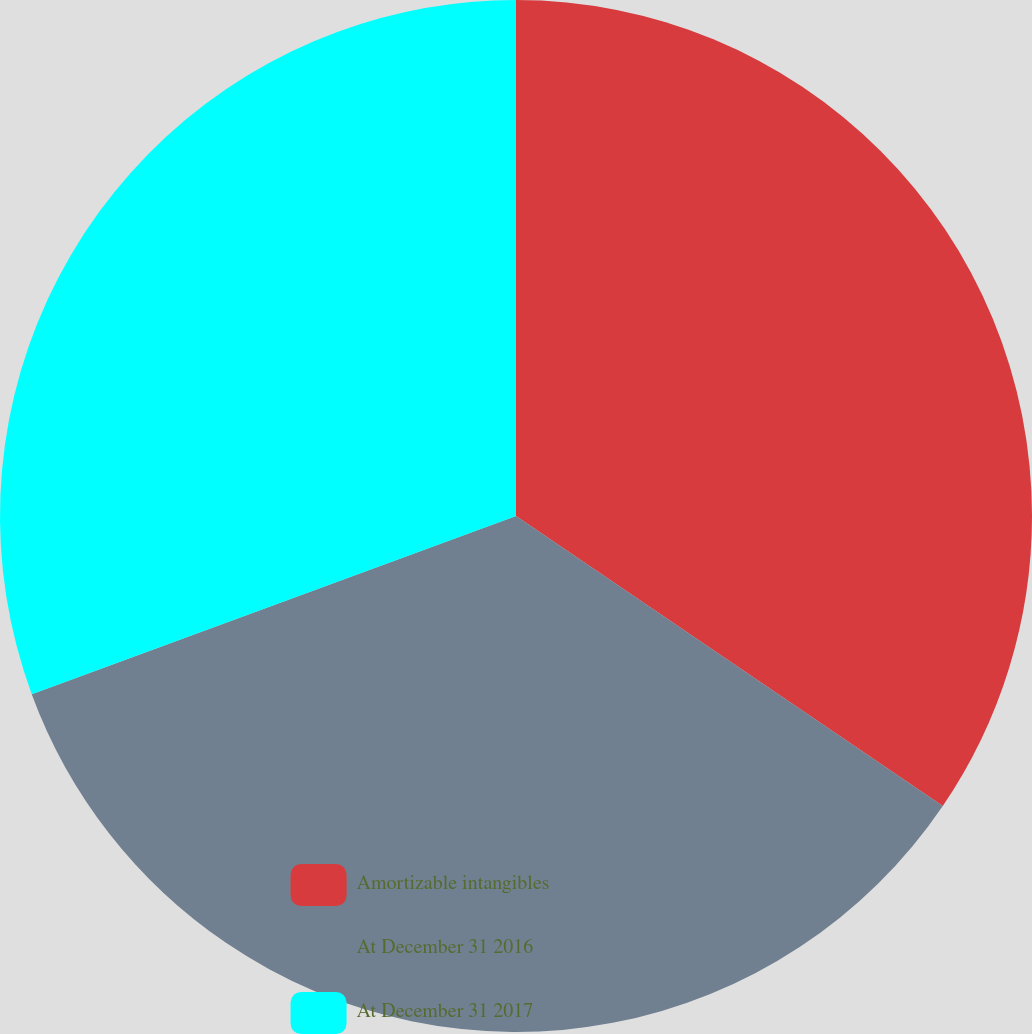Convert chart. <chart><loc_0><loc_0><loc_500><loc_500><pie_chart><fcel>Amortizable intangibles<fcel>At December 31 2016<fcel>At December 31 2017<nl><fcel>34.5%<fcel>34.89%<fcel>30.61%<nl></chart> 